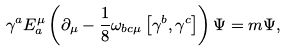<formula> <loc_0><loc_0><loc_500><loc_500>\gamma ^ { a } E _ { a } ^ { \mu } \left ( \partial _ { \mu } - \frac { 1 } { 8 } \omega _ { b c \mu } \left [ \gamma ^ { b } , \gamma ^ { c } \right ] \right ) \Psi = m \Psi ,</formula> 